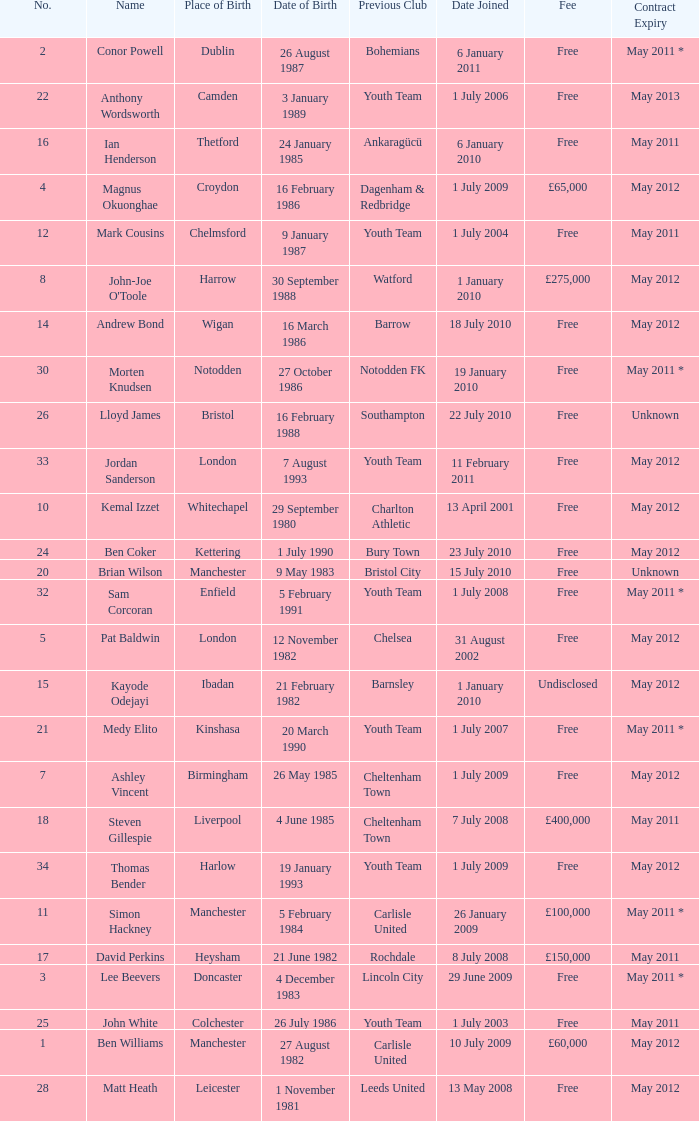What is the fee for ankaragücü previous club Free. I'm looking to parse the entire table for insights. Could you assist me with that? {'header': ['No.', 'Name', 'Place of Birth', 'Date of Birth', 'Previous Club', 'Date Joined', 'Fee', 'Contract Expiry'], 'rows': [['2', 'Conor Powell', 'Dublin', '26 August 1987', 'Bohemians', '6 January 2011', 'Free', 'May 2011 *'], ['22', 'Anthony Wordsworth', 'Camden', '3 January 1989', 'Youth Team', '1 July 2006', 'Free', 'May 2013'], ['16', 'Ian Henderson', 'Thetford', '24 January 1985', 'Ankaragücü', '6 January 2010', 'Free', 'May 2011'], ['4', 'Magnus Okuonghae', 'Croydon', '16 February 1986', 'Dagenham & Redbridge', '1 July 2009', '£65,000', 'May 2012'], ['12', 'Mark Cousins', 'Chelmsford', '9 January 1987', 'Youth Team', '1 July 2004', 'Free', 'May 2011'], ['8', "John-Joe O'Toole", 'Harrow', '30 September 1988', 'Watford', '1 January 2010', '£275,000', 'May 2012'], ['14', 'Andrew Bond', 'Wigan', '16 March 1986', 'Barrow', '18 July 2010', 'Free', 'May 2012'], ['30', 'Morten Knudsen', 'Notodden', '27 October 1986', 'Notodden FK', '19 January 2010', 'Free', 'May 2011 *'], ['26', 'Lloyd James', 'Bristol', '16 February 1988', 'Southampton', '22 July 2010', 'Free', 'Unknown'], ['33', 'Jordan Sanderson', 'London', '7 August 1993', 'Youth Team', '11 February 2011', 'Free', 'May 2012'], ['10', 'Kemal Izzet', 'Whitechapel', '29 September 1980', 'Charlton Athletic', '13 April 2001', 'Free', 'May 2012'], ['24', 'Ben Coker', 'Kettering', '1 July 1990', 'Bury Town', '23 July 2010', 'Free', 'May 2012'], ['20', 'Brian Wilson', 'Manchester', '9 May 1983', 'Bristol City', '15 July 2010', 'Free', 'Unknown'], ['32', 'Sam Corcoran', 'Enfield', '5 February 1991', 'Youth Team', '1 July 2008', 'Free', 'May 2011 *'], ['5', 'Pat Baldwin', 'London', '12 November 1982', 'Chelsea', '31 August 2002', 'Free', 'May 2012'], ['15', 'Kayode Odejayi', 'Ibadan', '21 February 1982', 'Barnsley', '1 January 2010', 'Undisclosed', 'May 2012'], ['21', 'Medy Elito', 'Kinshasa', '20 March 1990', 'Youth Team', '1 July 2007', 'Free', 'May 2011 *'], ['7', 'Ashley Vincent', 'Birmingham', '26 May 1985', 'Cheltenham Town', '1 July 2009', 'Free', 'May 2012'], ['18', 'Steven Gillespie', 'Liverpool', '4 June 1985', 'Cheltenham Town', '7 July 2008', '£400,000', 'May 2011'], ['34', 'Thomas Bender', 'Harlow', '19 January 1993', 'Youth Team', '1 July 2009', 'Free', 'May 2012'], ['11', 'Simon Hackney', 'Manchester', '5 February 1984', 'Carlisle United', '26 January 2009', '£100,000', 'May 2011 *'], ['17', 'David Perkins', 'Heysham', '21 June 1982', 'Rochdale', '8 July 2008', '£150,000', 'May 2011'], ['3', 'Lee Beevers', 'Doncaster', '4 December 1983', 'Lincoln City', '29 June 2009', 'Free', 'May 2011 *'], ['25', 'John White', 'Colchester', '26 July 1986', 'Youth Team', '1 July 2003', 'Free', 'May 2011'], ['1', 'Ben Williams', 'Manchester', '27 August 1982', 'Carlisle United', '10 July 2009', '£60,000', 'May 2012'], ['28', 'Matt Heath', 'Leicester', '1 November 1981', 'Leeds United', '13 May 2008', 'Free', 'May 2012']]} 